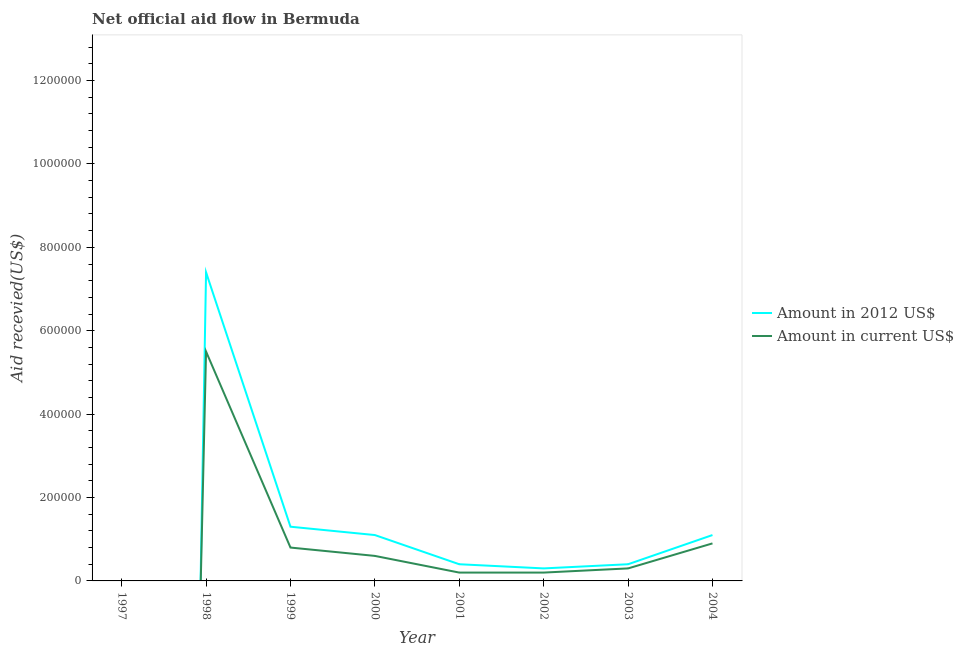What is the amount of aid received(expressed in 2012 us$) in 1997?
Offer a very short reply. 0. Across all years, what is the maximum amount of aid received(expressed in us$)?
Give a very brief answer. 5.50e+05. In which year was the amount of aid received(expressed in 2012 us$) maximum?
Give a very brief answer. 1998. What is the total amount of aid received(expressed in 2012 us$) in the graph?
Ensure brevity in your answer.  1.20e+06. What is the difference between the amount of aid received(expressed in 2012 us$) in 1999 and that in 2000?
Offer a very short reply. 2.00e+04. What is the difference between the amount of aid received(expressed in 2012 us$) in 2000 and the amount of aid received(expressed in us$) in 2001?
Offer a very short reply. 9.00e+04. What is the average amount of aid received(expressed in 2012 us$) per year?
Keep it short and to the point. 1.50e+05. In the year 2001, what is the difference between the amount of aid received(expressed in us$) and amount of aid received(expressed in 2012 us$)?
Offer a terse response. -2.00e+04. What is the ratio of the amount of aid received(expressed in us$) in 1999 to that in 2000?
Make the answer very short. 1.33. Is the amount of aid received(expressed in 2012 us$) in 1998 less than that in 2001?
Make the answer very short. No. What is the difference between the highest and the second highest amount of aid received(expressed in 2012 us$)?
Offer a very short reply. 6.10e+05. What is the difference between the highest and the lowest amount of aid received(expressed in 2012 us$)?
Make the answer very short. 7.40e+05. Is the sum of the amount of aid received(expressed in 2012 us$) in 1998 and 1999 greater than the maximum amount of aid received(expressed in us$) across all years?
Provide a succinct answer. Yes. Is the amount of aid received(expressed in 2012 us$) strictly less than the amount of aid received(expressed in us$) over the years?
Your answer should be very brief. No. How many years are there in the graph?
Give a very brief answer. 8. Are the values on the major ticks of Y-axis written in scientific E-notation?
Ensure brevity in your answer.  No. Where does the legend appear in the graph?
Make the answer very short. Center right. How many legend labels are there?
Ensure brevity in your answer.  2. What is the title of the graph?
Your response must be concise. Net official aid flow in Bermuda. Does "Total Population" appear as one of the legend labels in the graph?
Offer a very short reply. No. What is the label or title of the X-axis?
Ensure brevity in your answer.  Year. What is the label or title of the Y-axis?
Keep it short and to the point. Aid recevied(US$). What is the Aid recevied(US$) of Amount in 2012 US$ in 1997?
Give a very brief answer. 0. What is the Aid recevied(US$) in Amount in 2012 US$ in 1998?
Offer a terse response. 7.40e+05. What is the Aid recevied(US$) in Amount in current US$ in 1999?
Your response must be concise. 8.00e+04. What is the Aid recevied(US$) of Amount in current US$ in 2000?
Your answer should be compact. 6.00e+04. What is the Aid recevied(US$) of Amount in current US$ in 2001?
Your answer should be very brief. 2.00e+04. What is the Aid recevied(US$) of Amount in 2012 US$ in 2002?
Give a very brief answer. 3.00e+04. What is the Aid recevied(US$) of Amount in current US$ in 2002?
Your answer should be very brief. 2.00e+04. What is the Aid recevied(US$) in Amount in 2012 US$ in 2003?
Keep it short and to the point. 4.00e+04. What is the Aid recevied(US$) in Amount in current US$ in 2003?
Offer a terse response. 3.00e+04. Across all years, what is the maximum Aid recevied(US$) of Amount in 2012 US$?
Make the answer very short. 7.40e+05. Across all years, what is the minimum Aid recevied(US$) in Amount in 2012 US$?
Offer a very short reply. 0. What is the total Aid recevied(US$) of Amount in 2012 US$ in the graph?
Offer a very short reply. 1.20e+06. What is the total Aid recevied(US$) in Amount in current US$ in the graph?
Offer a very short reply. 8.50e+05. What is the difference between the Aid recevied(US$) of Amount in current US$ in 1998 and that in 1999?
Offer a terse response. 4.70e+05. What is the difference between the Aid recevied(US$) in Amount in 2012 US$ in 1998 and that in 2000?
Ensure brevity in your answer.  6.30e+05. What is the difference between the Aid recevied(US$) in Amount in current US$ in 1998 and that in 2000?
Provide a short and direct response. 4.90e+05. What is the difference between the Aid recevied(US$) in Amount in current US$ in 1998 and that in 2001?
Make the answer very short. 5.30e+05. What is the difference between the Aid recevied(US$) of Amount in 2012 US$ in 1998 and that in 2002?
Your answer should be compact. 7.10e+05. What is the difference between the Aid recevied(US$) of Amount in current US$ in 1998 and that in 2002?
Provide a short and direct response. 5.30e+05. What is the difference between the Aid recevied(US$) of Amount in current US$ in 1998 and that in 2003?
Provide a short and direct response. 5.20e+05. What is the difference between the Aid recevied(US$) of Amount in 2012 US$ in 1998 and that in 2004?
Your response must be concise. 6.30e+05. What is the difference between the Aid recevied(US$) in Amount in current US$ in 1998 and that in 2004?
Provide a succinct answer. 4.60e+05. What is the difference between the Aid recevied(US$) in Amount in 2012 US$ in 1999 and that in 2001?
Your answer should be compact. 9.00e+04. What is the difference between the Aid recevied(US$) in Amount in current US$ in 1999 and that in 2002?
Make the answer very short. 6.00e+04. What is the difference between the Aid recevied(US$) of Amount in current US$ in 1999 and that in 2003?
Offer a terse response. 5.00e+04. What is the difference between the Aid recevied(US$) in Amount in current US$ in 2000 and that in 2001?
Ensure brevity in your answer.  4.00e+04. What is the difference between the Aid recevied(US$) in Amount in 2012 US$ in 2000 and that in 2002?
Provide a succinct answer. 8.00e+04. What is the difference between the Aid recevied(US$) of Amount in 2012 US$ in 2000 and that in 2004?
Your response must be concise. 0. What is the difference between the Aid recevied(US$) of Amount in 2012 US$ in 2001 and that in 2002?
Offer a very short reply. 10000. What is the difference between the Aid recevied(US$) in Amount in current US$ in 2001 and that in 2003?
Make the answer very short. -10000. What is the difference between the Aid recevied(US$) of Amount in 2012 US$ in 2001 and that in 2004?
Your answer should be compact. -7.00e+04. What is the difference between the Aid recevied(US$) of Amount in current US$ in 2001 and that in 2004?
Offer a terse response. -7.00e+04. What is the difference between the Aid recevied(US$) in Amount in 2012 US$ in 2002 and that in 2003?
Offer a very short reply. -10000. What is the difference between the Aid recevied(US$) in Amount in current US$ in 2002 and that in 2003?
Ensure brevity in your answer.  -10000. What is the difference between the Aid recevied(US$) of Amount in current US$ in 2002 and that in 2004?
Give a very brief answer. -7.00e+04. What is the difference between the Aid recevied(US$) of Amount in 2012 US$ in 2003 and that in 2004?
Offer a terse response. -7.00e+04. What is the difference between the Aid recevied(US$) in Amount in 2012 US$ in 1998 and the Aid recevied(US$) in Amount in current US$ in 2000?
Provide a short and direct response. 6.80e+05. What is the difference between the Aid recevied(US$) in Amount in 2012 US$ in 1998 and the Aid recevied(US$) in Amount in current US$ in 2001?
Give a very brief answer. 7.20e+05. What is the difference between the Aid recevied(US$) of Amount in 2012 US$ in 1998 and the Aid recevied(US$) of Amount in current US$ in 2002?
Your answer should be compact. 7.20e+05. What is the difference between the Aid recevied(US$) in Amount in 2012 US$ in 1998 and the Aid recevied(US$) in Amount in current US$ in 2003?
Your answer should be compact. 7.10e+05. What is the difference between the Aid recevied(US$) of Amount in 2012 US$ in 1998 and the Aid recevied(US$) of Amount in current US$ in 2004?
Offer a terse response. 6.50e+05. What is the difference between the Aid recevied(US$) of Amount in 2012 US$ in 1999 and the Aid recevied(US$) of Amount in current US$ in 2000?
Your answer should be very brief. 7.00e+04. What is the difference between the Aid recevied(US$) of Amount in 2012 US$ in 1999 and the Aid recevied(US$) of Amount in current US$ in 2001?
Offer a very short reply. 1.10e+05. What is the difference between the Aid recevied(US$) of Amount in 2012 US$ in 1999 and the Aid recevied(US$) of Amount in current US$ in 2002?
Offer a terse response. 1.10e+05. What is the difference between the Aid recevied(US$) of Amount in 2012 US$ in 1999 and the Aid recevied(US$) of Amount in current US$ in 2003?
Ensure brevity in your answer.  1.00e+05. What is the difference between the Aid recevied(US$) in Amount in 2012 US$ in 2000 and the Aid recevied(US$) in Amount in current US$ in 2003?
Provide a short and direct response. 8.00e+04. What is the difference between the Aid recevied(US$) in Amount in 2012 US$ in 2001 and the Aid recevied(US$) in Amount in current US$ in 2002?
Provide a succinct answer. 2.00e+04. What is the difference between the Aid recevied(US$) in Amount in 2012 US$ in 2001 and the Aid recevied(US$) in Amount in current US$ in 2004?
Provide a succinct answer. -5.00e+04. What is the average Aid recevied(US$) of Amount in 2012 US$ per year?
Give a very brief answer. 1.50e+05. What is the average Aid recevied(US$) of Amount in current US$ per year?
Your answer should be compact. 1.06e+05. In the year 1998, what is the difference between the Aid recevied(US$) in Amount in 2012 US$ and Aid recevied(US$) in Amount in current US$?
Your answer should be very brief. 1.90e+05. In the year 2002, what is the difference between the Aid recevied(US$) of Amount in 2012 US$ and Aid recevied(US$) of Amount in current US$?
Your answer should be compact. 10000. What is the ratio of the Aid recevied(US$) in Amount in 2012 US$ in 1998 to that in 1999?
Provide a short and direct response. 5.69. What is the ratio of the Aid recevied(US$) of Amount in current US$ in 1998 to that in 1999?
Offer a terse response. 6.88. What is the ratio of the Aid recevied(US$) of Amount in 2012 US$ in 1998 to that in 2000?
Offer a very short reply. 6.73. What is the ratio of the Aid recevied(US$) of Amount in current US$ in 1998 to that in 2000?
Make the answer very short. 9.17. What is the ratio of the Aid recevied(US$) of Amount in 2012 US$ in 1998 to that in 2001?
Provide a succinct answer. 18.5. What is the ratio of the Aid recevied(US$) of Amount in 2012 US$ in 1998 to that in 2002?
Offer a very short reply. 24.67. What is the ratio of the Aid recevied(US$) of Amount in current US$ in 1998 to that in 2002?
Offer a very short reply. 27.5. What is the ratio of the Aid recevied(US$) of Amount in current US$ in 1998 to that in 2003?
Your answer should be very brief. 18.33. What is the ratio of the Aid recevied(US$) in Amount in 2012 US$ in 1998 to that in 2004?
Ensure brevity in your answer.  6.73. What is the ratio of the Aid recevied(US$) in Amount in current US$ in 1998 to that in 2004?
Offer a terse response. 6.11. What is the ratio of the Aid recevied(US$) in Amount in 2012 US$ in 1999 to that in 2000?
Your answer should be very brief. 1.18. What is the ratio of the Aid recevied(US$) in Amount in 2012 US$ in 1999 to that in 2001?
Your answer should be very brief. 3.25. What is the ratio of the Aid recevied(US$) of Amount in 2012 US$ in 1999 to that in 2002?
Provide a succinct answer. 4.33. What is the ratio of the Aid recevied(US$) of Amount in 2012 US$ in 1999 to that in 2003?
Keep it short and to the point. 3.25. What is the ratio of the Aid recevied(US$) in Amount in current US$ in 1999 to that in 2003?
Offer a terse response. 2.67. What is the ratio of the Aid recevied(US$) of Amount in 2012 US$ in 1999 to that in 2004?
Ensure brevity in your answer.  1.18. What is the ratio of the Aid recevied(US$) of Amount in 2012 US$ in 2000 to that in 2001?
Your response must be concise. 2.75. What is the ratio of the Aid recevied(US$) in Amount in current US$ in 2000 to that in 2001?
Ensure brevity in your answer.  3. What is the ratio of the Aid recevied(US$) of Amount in 2012 US$ in 2000 to that in 2002?
Your answer should be very brief. 3.67. What is the ratio of the Aid recevied(US$) of Amount in current US$ in 2000 to that in 2002?
Keep it short and to the point. 3. What is the ratio of the Aid recevied(US$) of Amount in 2012 US$ in 2000 to that in 2003?
Provide a short and direct response. 2.75. What is the ratio of the Aid recevied(US$) in Amount in current US$ in 2000 to that in 2004?
Your response must be concise. 0.67. What is the ratio of the Aid recevied(US$) of Amount in current US$ in 2001 to that in 2002?
Give a very brief answer. 1. What is the ratio of the Aid recevied(US$) of Amount in 2012 US$ in 2001 to that in 2003?
Your answer should be compact. 1. What is the ratio of the Aid recevied(US$) of Amount in 2012 US$ in 2001 to that in 2004?
Provide a succinct answer. 0.36. What is the ratio of the Aid recevied(US$) in Amount in current US$ in 2001 to that in 2004?
Ensure brevity in your answer.  0.22. What is the ratio of the Aid recevied(US$) in Amount in 2012 US$ in 2002 to that in 2003?
Provide a short and direct response. 0.75. What is the ratio of the Aid recevied(US$) of Amount in current US$ in 2002 to that in 2003?
Ensure brevity in your answer.  0.67. What is the ratio of the Aid recevied(US$) of Amount in 2012 US$ in 2002 to that in 2004?
Offer a very short reply. 0.27. What is the ratio of the Aid recevied(US$) in Amount in current US$ in 2002 to that in 2004?
Offer a terse response. 0.22. What is the ratio of the Aid recevied(US$) of Amount in 2012 US$ in 2003 to that in 2004?
Ensure brevity in your answer.  0.36. What is the ratio of the Aid recevied(US$) in Amount in current US$ in 2003 to that in 2004?
Offer a terse response. 0.33. What is the difference between the highest and the second highest Aid recevied(US$) in Amount in 2012 US$?
Provide a succinct answer. 6.10e+05. What is the difference between the highest and the second highest Aid recevied(US$) in Amount in current US$?
Give a very brief answer. 4.60e+05. What is the difference between the highest and the lowest Aid recevied(US$) of Amount in 2012 US$?
Offer a terse response. 7.40e+05. 